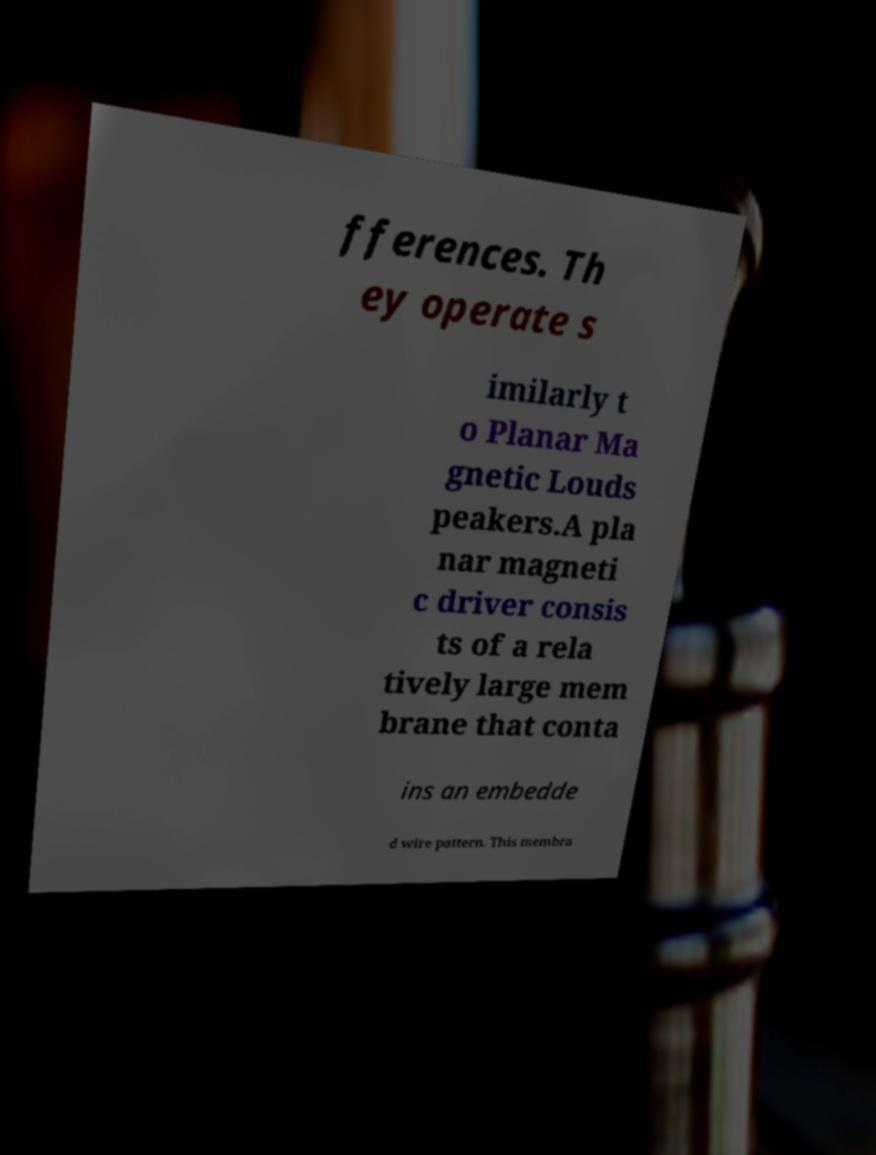I need the written content from this picture converted into text. Can you do that? fferences. Th ey operate s imilarly t o Planar Ma gnetic Louds peakers.A pla nar magneti c driver consis ts of a rela tively large mem brane that conta ins an embedde d wire pattern. This membra 